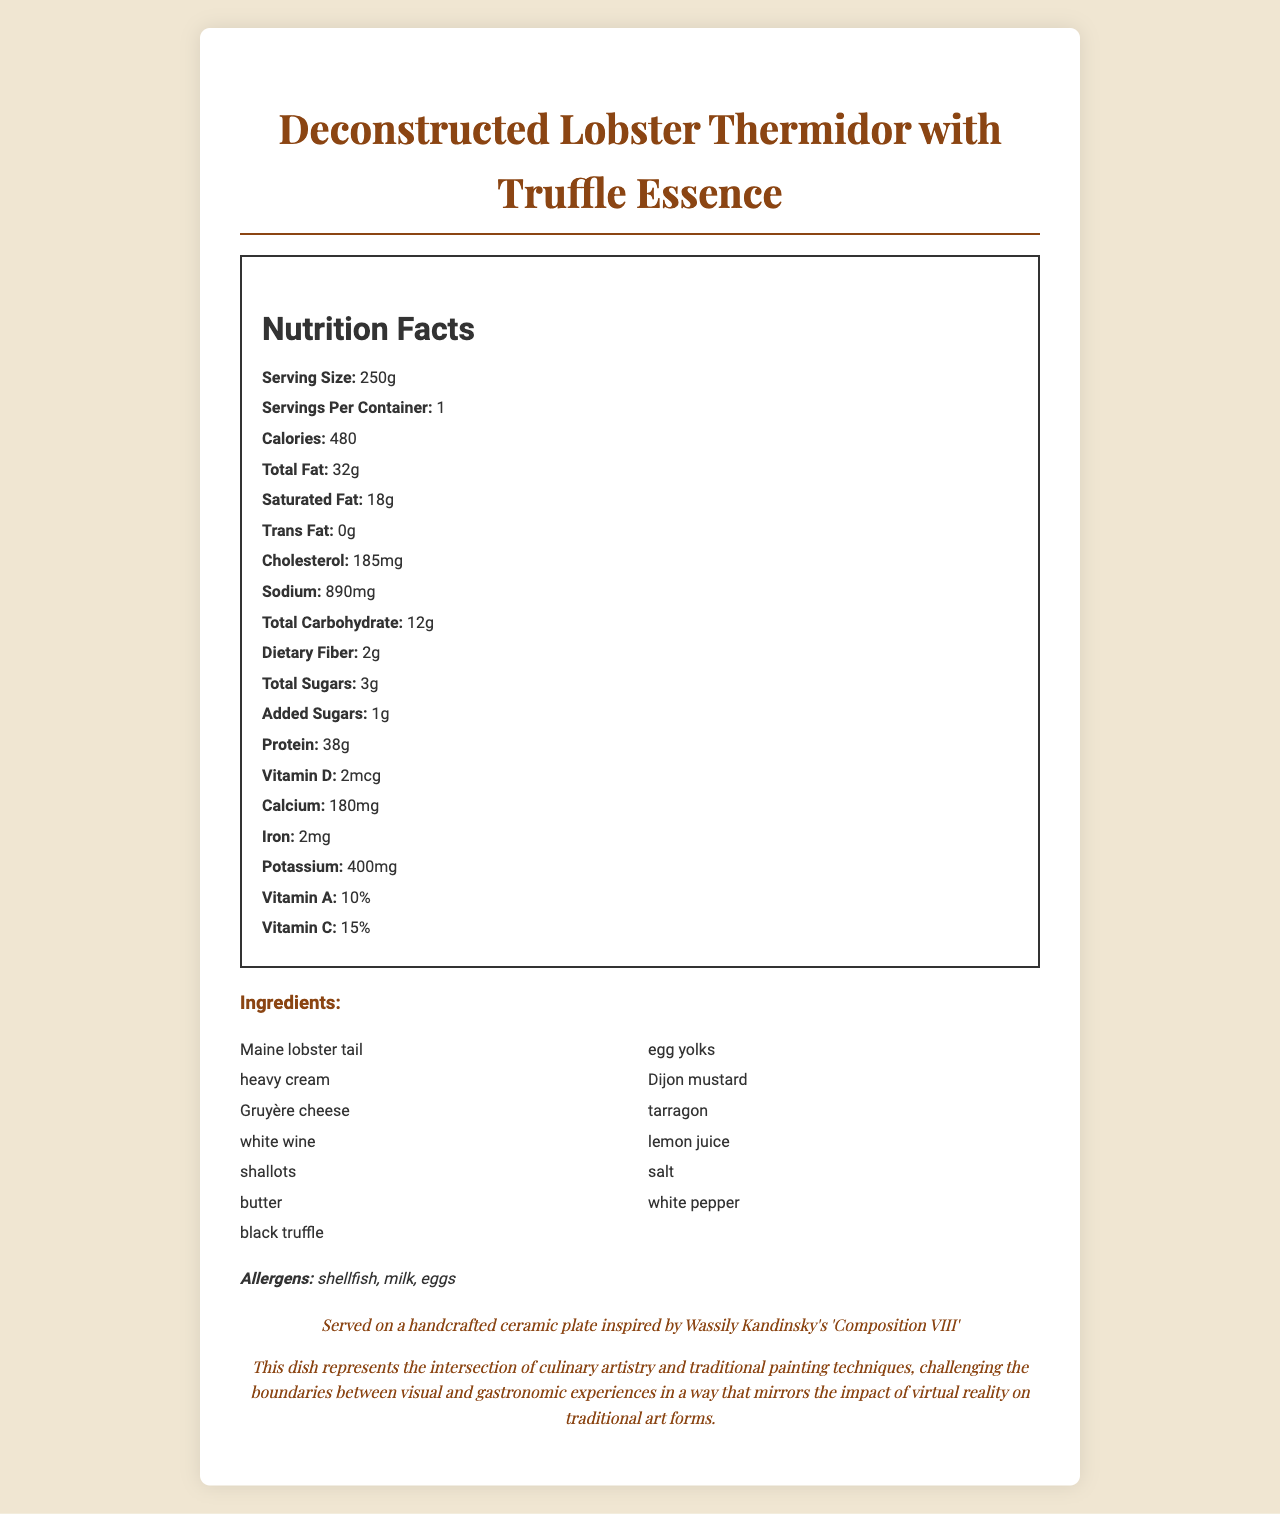what is the serving size for the dish? The serving size is clearly mentioned as "250g" in the nutrition label of the document.
Answer: 250g how many calories does one serving of the dish contain? The document states that one serving of the dish contains 480 calories.
Answer: 480 which ingredients are allergens? The allergens are listed explicitly as shellfish, milk, and eggs in the document.
Answer: shellfish, milk, eggs what is the total amount of fat in grams? The total fat content is listed as 32 grams.
Answer: 32g how much sodium is in one serving? The sodium content per serving is given as 890 milligrams.
Answer: 890mg how much protein is in the dish? A. 28g B. 32g C. 38g D. 42g The document specifies that the dish contains 38 grams of protein per serving.
Answer: C. 38g how many grams of dietary fiber does the dish contain? A. 2g B. 4g C. 6g The document states that there are 2 grams of dietary fiber in one serving.
Answer: A. 2g is the dish prepared using traditional cooking methods? The preparation method is given as "Sous-vide and molecular gastronomy techniques," which are not traditional.
Answer: No does the dish contain any trans fat? The document explicitly states that the trans fat content is 0 grams.
Answer: No what is the main artistic theme reflected in the dish's presentation? The dish is presented on a handcrafted ceramic plate inspired by Wassily Kandinsky's 'Composition VIII'.
Answer: Wassily Kandinsky's 'Composition VIII' how is the Deconstructed Lobster Thermidor dish tied to sustainability? The document notes that the lobster is sourced from MSC-certified sustainable fisheries.
Answer: Lobster sourced from MSC-certified sustainable fisheries describe the main components and purpose of the document. The document provides detailed information about "Deconstructed Lobster Thermidor with Truffle Essence," including its nutritional content, ingredients, allergens, preparation methods, wine pairing, and artistic inspiration, emphasizing the intersection of culinary and visual arts.
Answer: The document is a comprehensive Nutrition Facts label for a gourmet meal served at an exclusive art exhibition opening. It includes nutritional breakdown, ingredients, allergens, preparation methods, artistic presentation, wine pairing, sustainability notes, and curator insights that link the dish to both culinary artistry and traditional art forms. how much Vitamin D is present in the dish? The document lists Vitamin D content as 2 micrograms.
Answer: 2mcg who is the chef responsible for creating this dish? The document does not specify who the chef is.
Answer: Not enough information which component is used to add truffle essence to the dish? Among the ingredients, "black truffle" suggests the source of the truffle essence used in the dish.
Answer: black truffle 